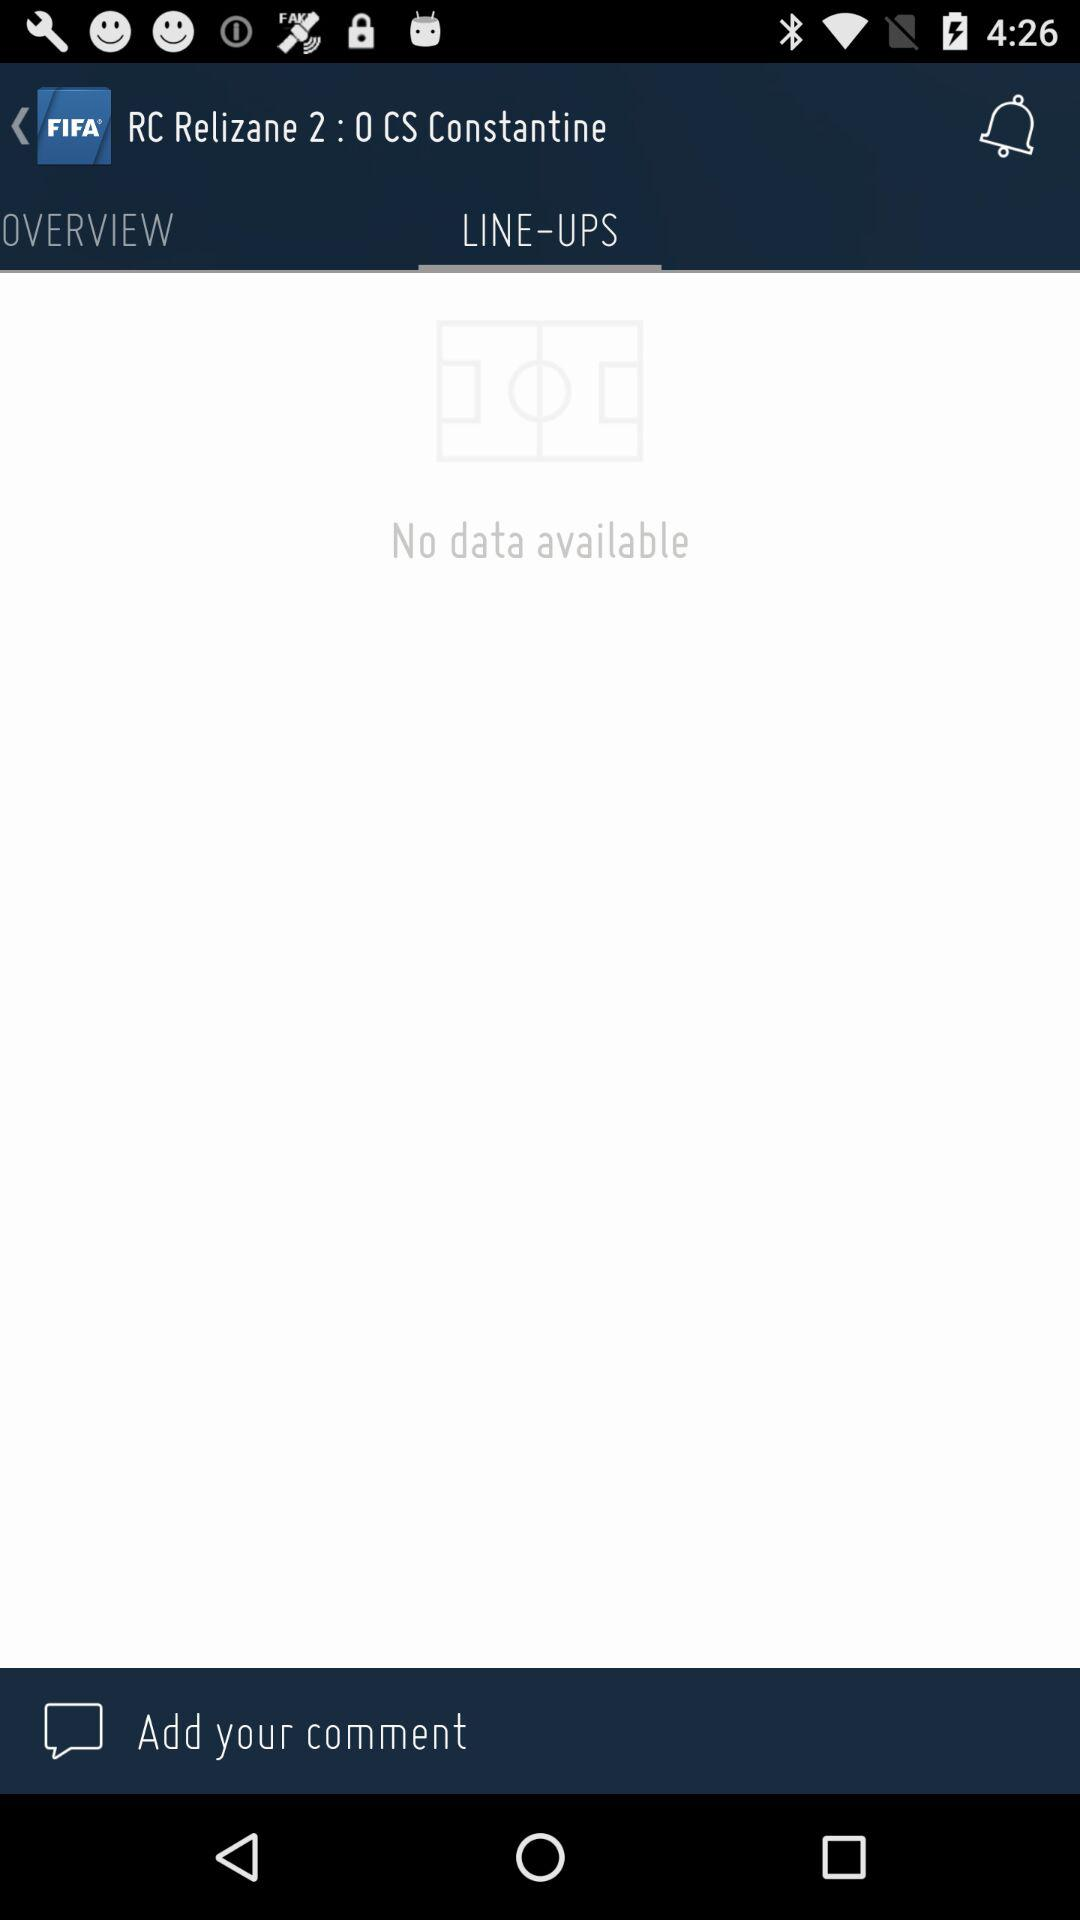Which tab am I on? You are on "LINE‒UPS" tab. 